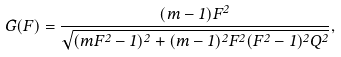Convert formula to latex. <formula><loc_0><loc_0><loc_500><loc_500>G ( F ) = \frac { ( m - 1 ) F ^ { 2 } } { \sqrt { ( m F ^ { 2 } - 1 ) ^ { 2 } + ( m - 1 ) ^ { 2 } F ^ { 2 } ( F ^ { 2 } - 1 ) ^ { 2 } Q ^ { 2 } } } ,</formula> 